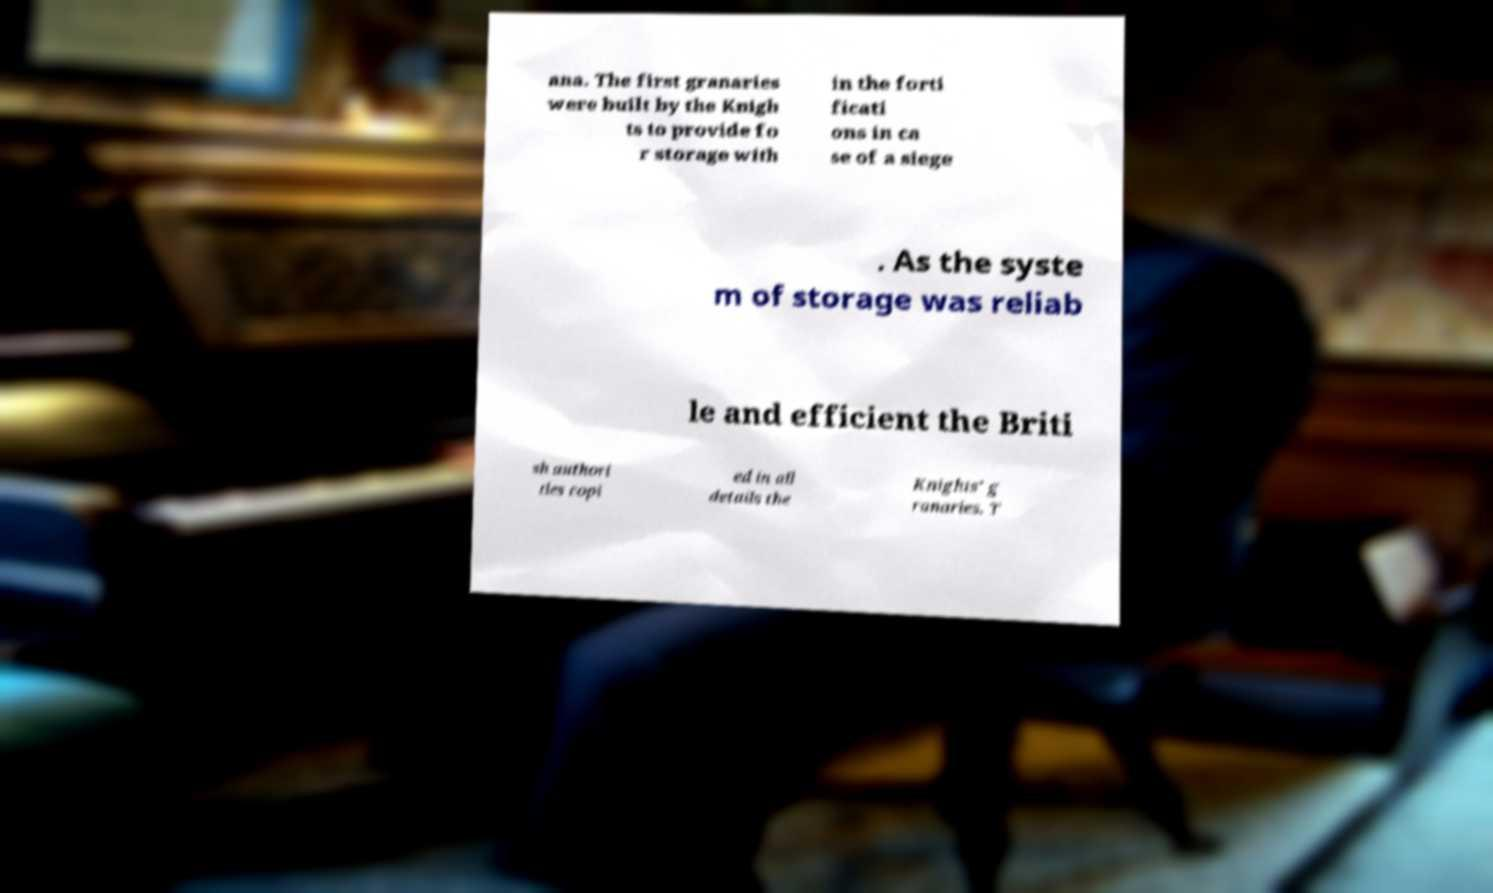Can you read and provide the text displayed in the image?This photo seems to have some interesting text. Can you extract and type it out for me? ana. The first granaries were built by the Knigh ts to provide fo r storage with in the forti ficati ons in ca se of a siege . As the syste m of storage was reliab le and efficient the Briti sh authori ties copi ed in all details the Knights’ g ranaries. T 